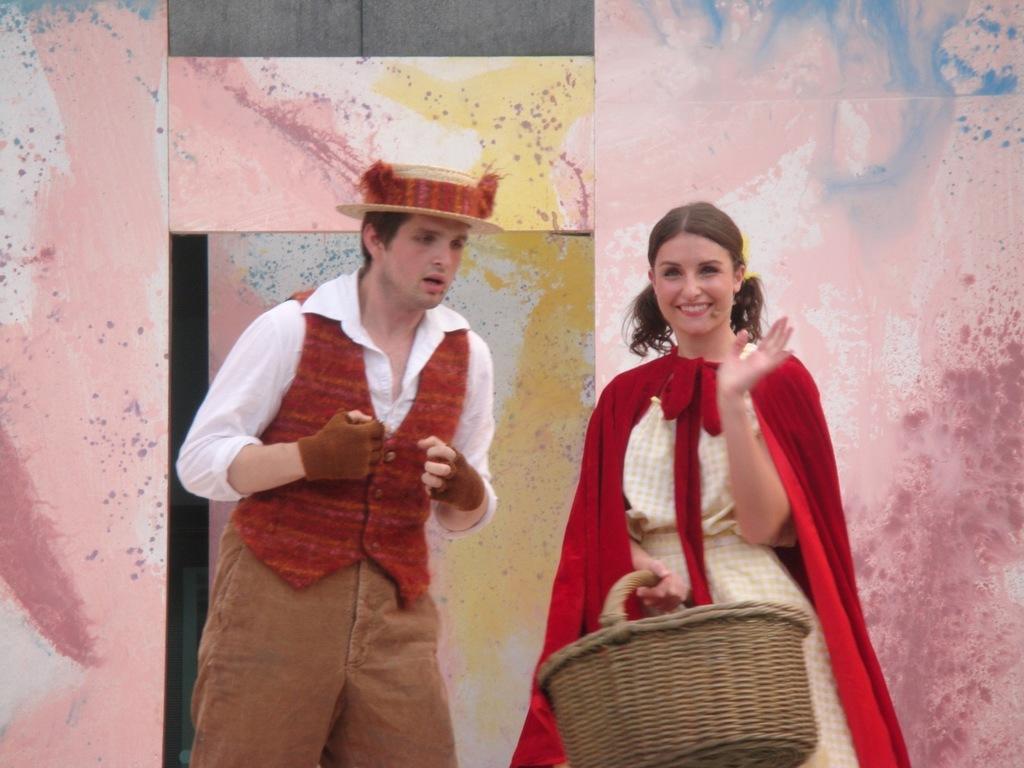Describe this image in one or two sentences. In this image there are two people standing with a smile on their face, one of them is holding a basket in her hand, beside them there is a wall and a door. 